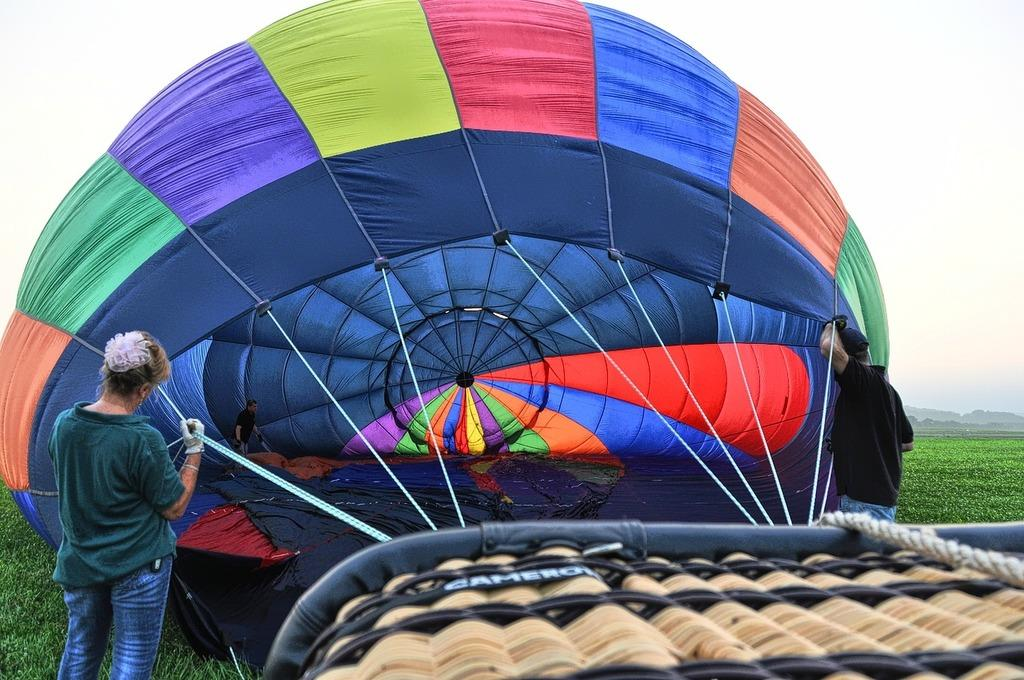What is the main object in the image? There is a parachute in the image. Who is holding the parachute? The parachute is being held by two people. What can be seen in the background of the image? There is a sky visible in the background of the image. What direction is the swing facing in the image? There is no swing present in the image. 